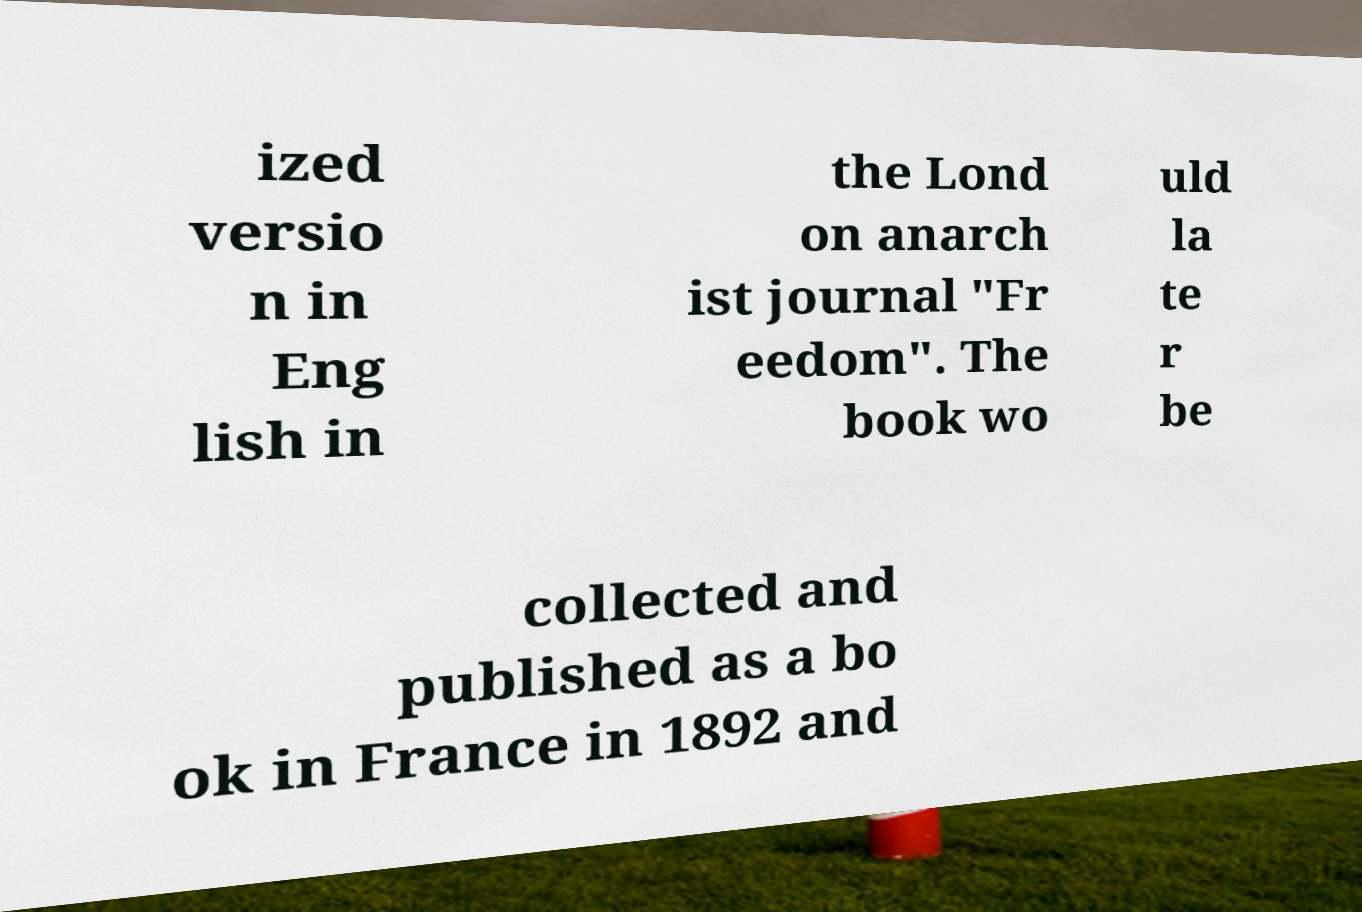What messages or text are displayed in this image? I need them in a readable, typed format. ized versio n in Eng lish in the Lond on anarch ist journal "Fr eedom". The book wo uld la te r be collected and published as a bo ok in France in 1892 and 